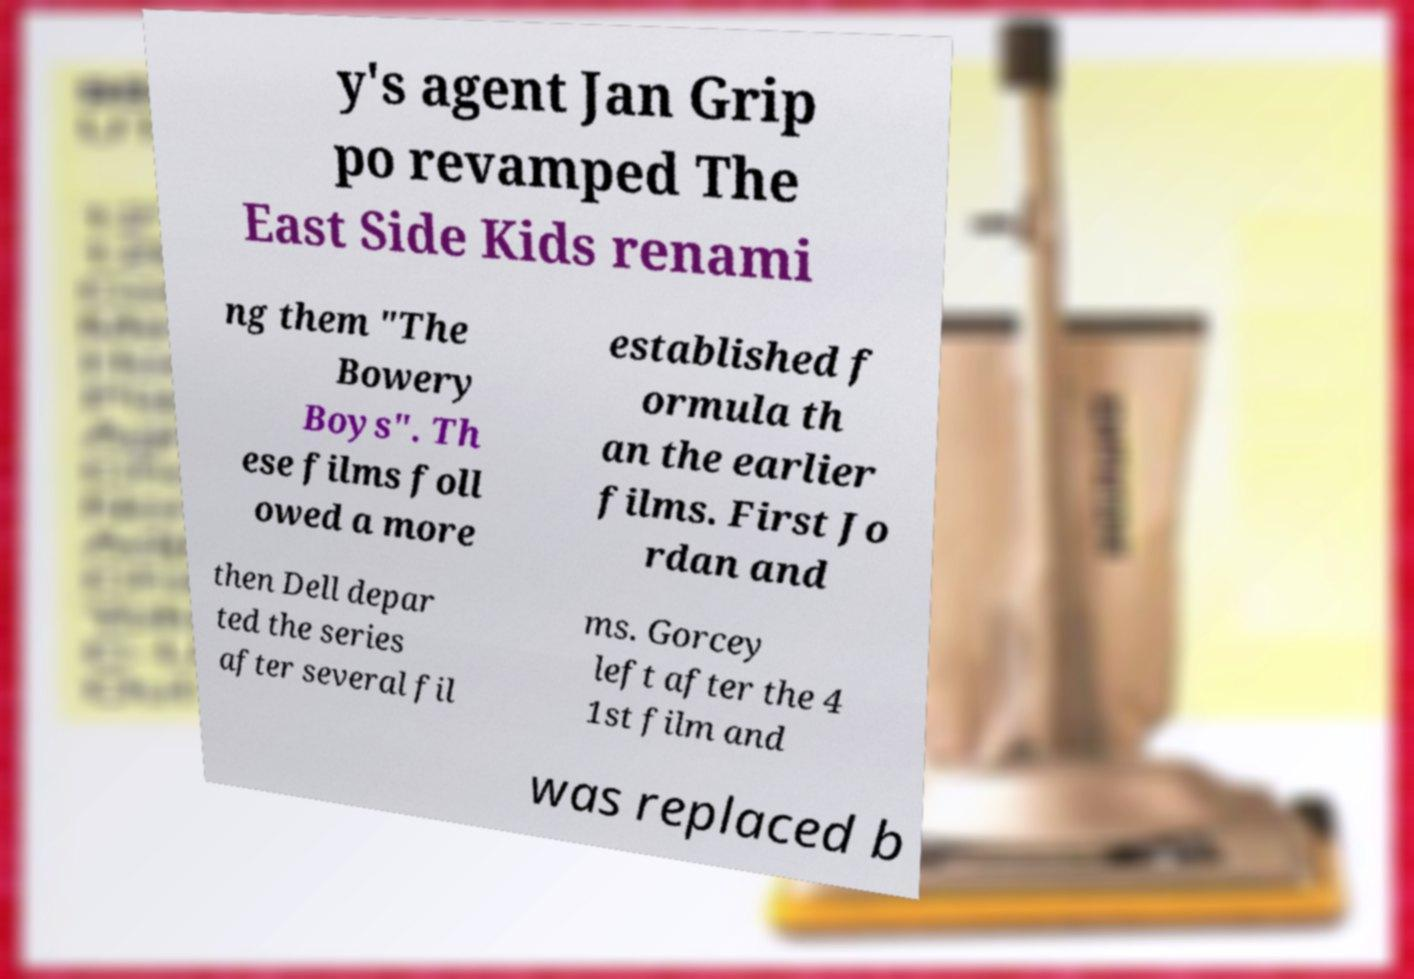Please identify and transcribe the text found in this image. y's agent Jan Grip po revamped The East Side Kids renami ng them "The Bowery Boys". Th ese films foll owed a more established f ormula th an the earlier films. First Jo rdan and then Dell depar ted the series after several fil ms. Gorcey left after the 4 1st film and was replaced b 